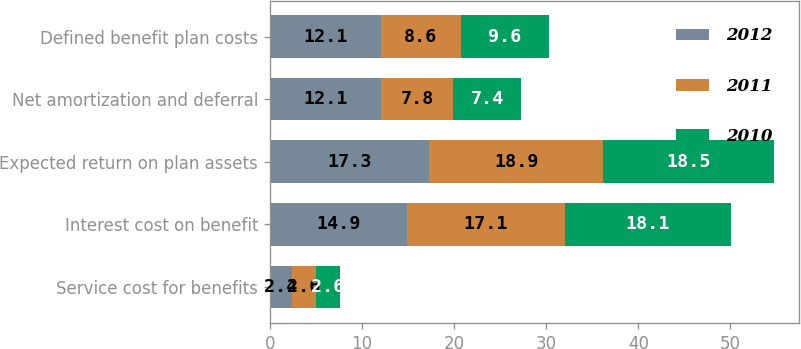Convert chart to OTSL. <chart><loc_0><loc_0><loc_500><loc_500><stacked_bar_chart><ecel><fcel>Service cost for benefits<fcel>Interest cost on benefit<fcel>Expected return on plan assets<fcel>Net amortization and deferral<fcel>Defined benefit plan costs<nl><fcel>2012<fcel>2.4<fcel>14.9<fcel>17.3<fcel>12.1<fcel>12.1<nl><fcel>2011<fcel>2.6<fcel>17.1<fcel>18.9<fcel>7.8<fcel>8.6<nl><fcel>2010<fcel>2.6<fcel>18.1<fcel>18.5<fcel>7.4<fcel>9.6<nl></chart> 